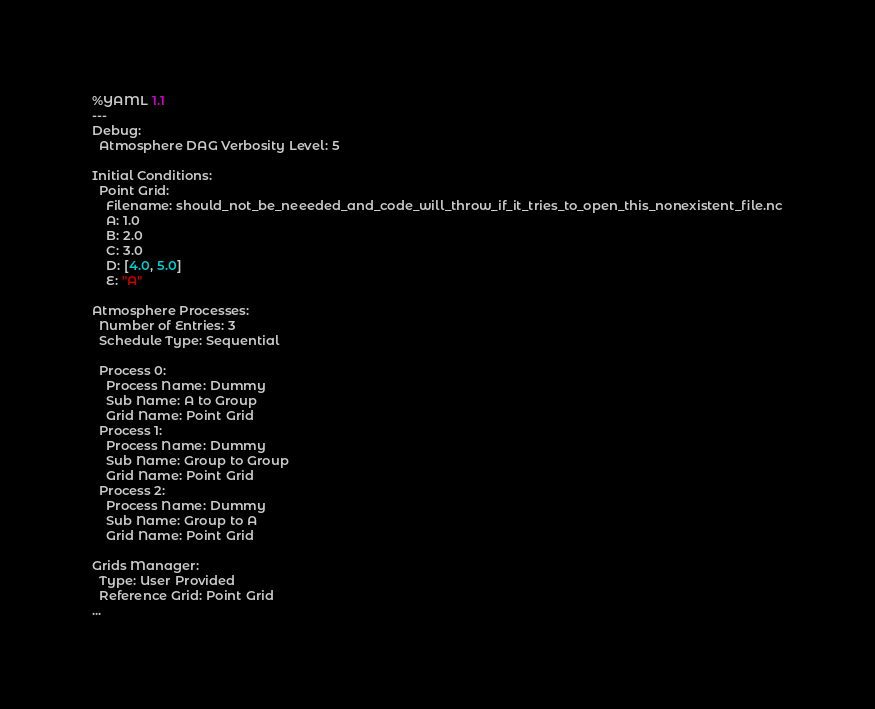Convert code to text. <code><loc_0><loc_0><loc_500><loc_500><_YAML_>%YAML 1.1
---
Debug:
  Atmosphere DAG Verbosity Level: 5

Initial Conditions:
  Point Grid:
    Filename: should_not_be_neeeded_and_code_will_throw_if_it_tries_to_open_this_nonexistent_file.nc
    A: 1.0
    B: 2.0
    C: 3.0
    D: [4.0, 5.0]
    E: "A"

Atmosphere Processes:
  Number of Entries: 3
  Schedule Type: Sequential

  Process 0:
    Process Name: Dummy
    Sub Name: A to Group
    Grid Name: Point Grid
  Process 1:
    Process Name: Dummy
    Sub Name: Group to Group
    Grid Name: Point Grid
  Process 2:
    Process Name: Dummy
    Sub Name: Group to A
    Grid Name: Point Grid

Grids Manager:
  Type: User Provided
  Reference Grid: Point Grid
...
</code> 